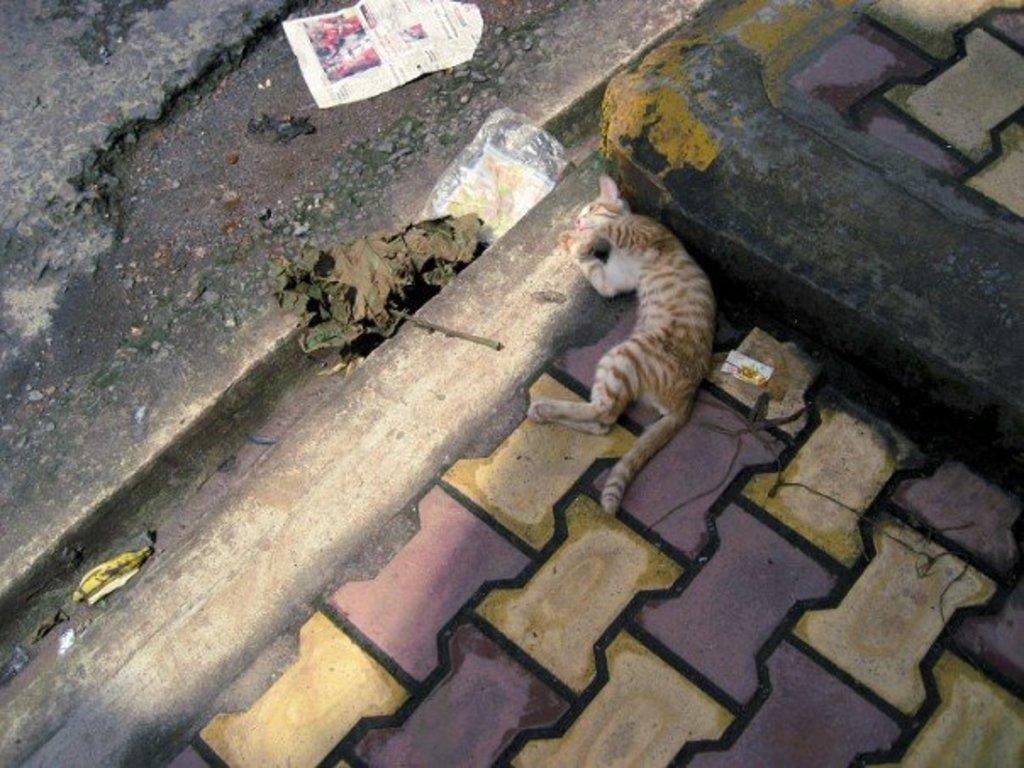Please provide a concise description of this image. In this image we can see a cat on the surface. We can also see a paper, cover, banana peel and a leaf on the ground. 